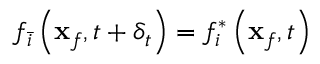<formula> <loc_0><loc_0><loc_500><loc_500>f _ { \bar { i } } \left ( x _ { f } , t + \delta _ { t } \right ) = f _ { i } ^ { * } \left ( x _ { f } , t \right )</formula> 